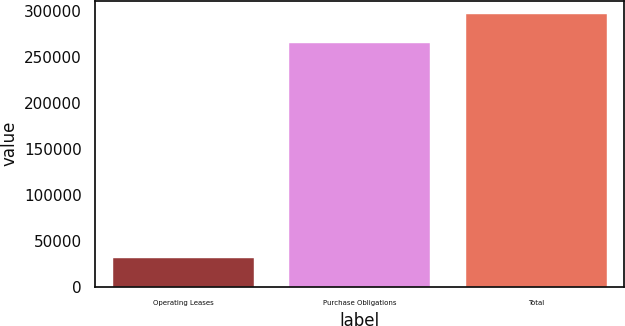Convert chart. <chart><loc_0><loc_0><loc_500><loc_500><bar_chart><fcel>Operating Leases<fcel>Purchase Obligations<fcel>Total<nl><fcel>31145<fcel>265409<fcel>296554<nl></chart> 